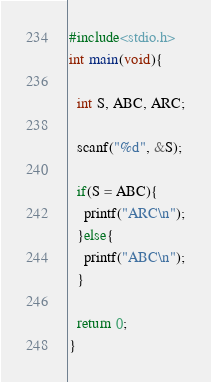Convert code to text. <code><loc_0><loc_0><loc_500><loc_500><_C_>#include<stdio.h>
int main(void){
   
  int S, ABC, ARC;
  
  scanf("%d", &S);
  
  if(S = ABC){
    printf("ARC\n");
  }else{
    printf("ABC\n");
  }
  
  return 0;
}</code> 